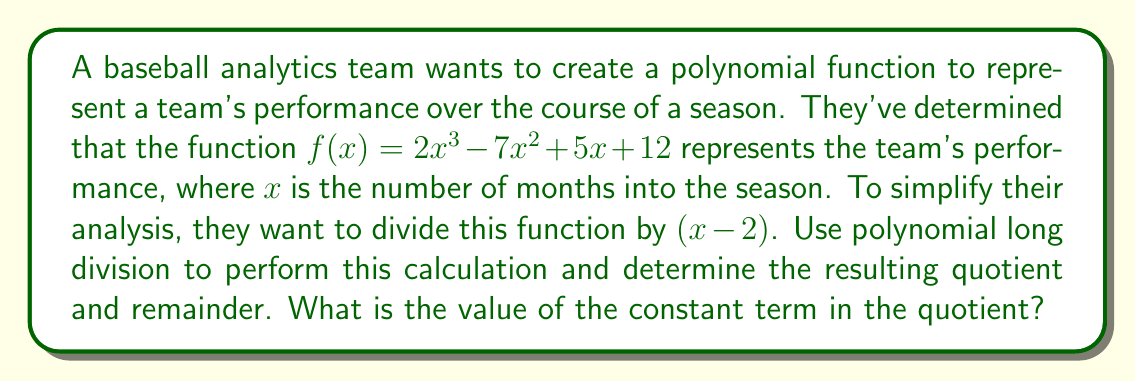Can you answer this question? Let's perform polynomial long division of $f(x) = 2x^3 - 7x^2 + 5x + 12$ by $(x - 2)$:

$$
\begin{array}{r}
2x^2 + x - 2 \\
x - 2 \enclose{longdiv}{2x^3 - 7x^2 + 5x + 12} \\
\underline{2x^3 - 4x^2} \\
-3x^2 + 5x \\
\underline{-3x^2 + 6x} \\
-x + 12 \\
\underline{-x + 2} \\
14
\end{array}
$$

Step 1: Divide $2x^3$ by $x$, giving $2x^2$.
Step 2: Multiply $(x - 2)$ by $2x^2$: $2x^3 - 4x^2$.
Step 3: Subtract: $2x^3 - 7x^2 - (2x^3 - 4x^2) = -3x^2 + 5x$.
Step 4: Bring down the $5x$ term.
Step 5: Divide $-3x^2$ by $x$, giving $-3x$.
Step 6: Multiply $(x - 2)$ by $-3x$: $-3x^2 + 6x$.
Step 7: Subtract: $-3x^2 + 5x - (-3x^2 + 6x) = -x + 12$.
Step 8: Bring down the constant term 12.
Step 9: Divide $-x$ by $x$, giving $-1$.
Step 10: Multiply $(x - 2)$ by $-1$: $-x + 2$.
Step 11: Subtract: $-x + 12 - (-x + 2) = 14$.

The result of the division is:
Quotient: $2x^2 + x - 2$
Remainder: $14$

The constant term in the quotient is $-2$.
Answer: $-2$ 